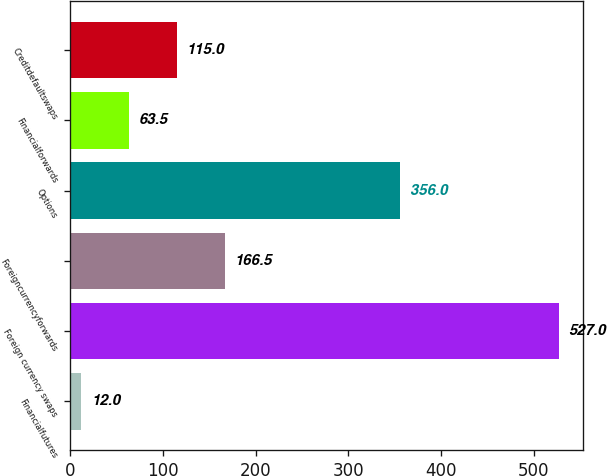Convert chart to OTSL. <chart><loc_0><loc_0><loc_500><loc_500><bar_chart><fcel>Financialfutures<fcel>Foreign currency swaps<fcel>Foreigncurrencyforwards<fcel>Options<fcel>Financialforwards<fcel>Creditdefaultswaps<nl><fcel>12<fcel>527<fcel>166.5<fcel>356<fcel>63.5<fcel>115<nl></chart> 